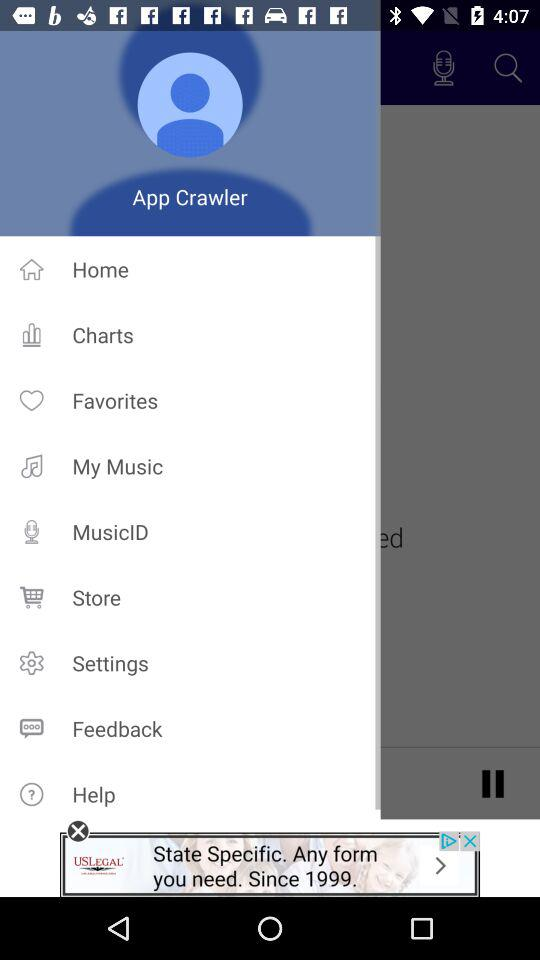What is the profile name? The profile name is App Crawler. 